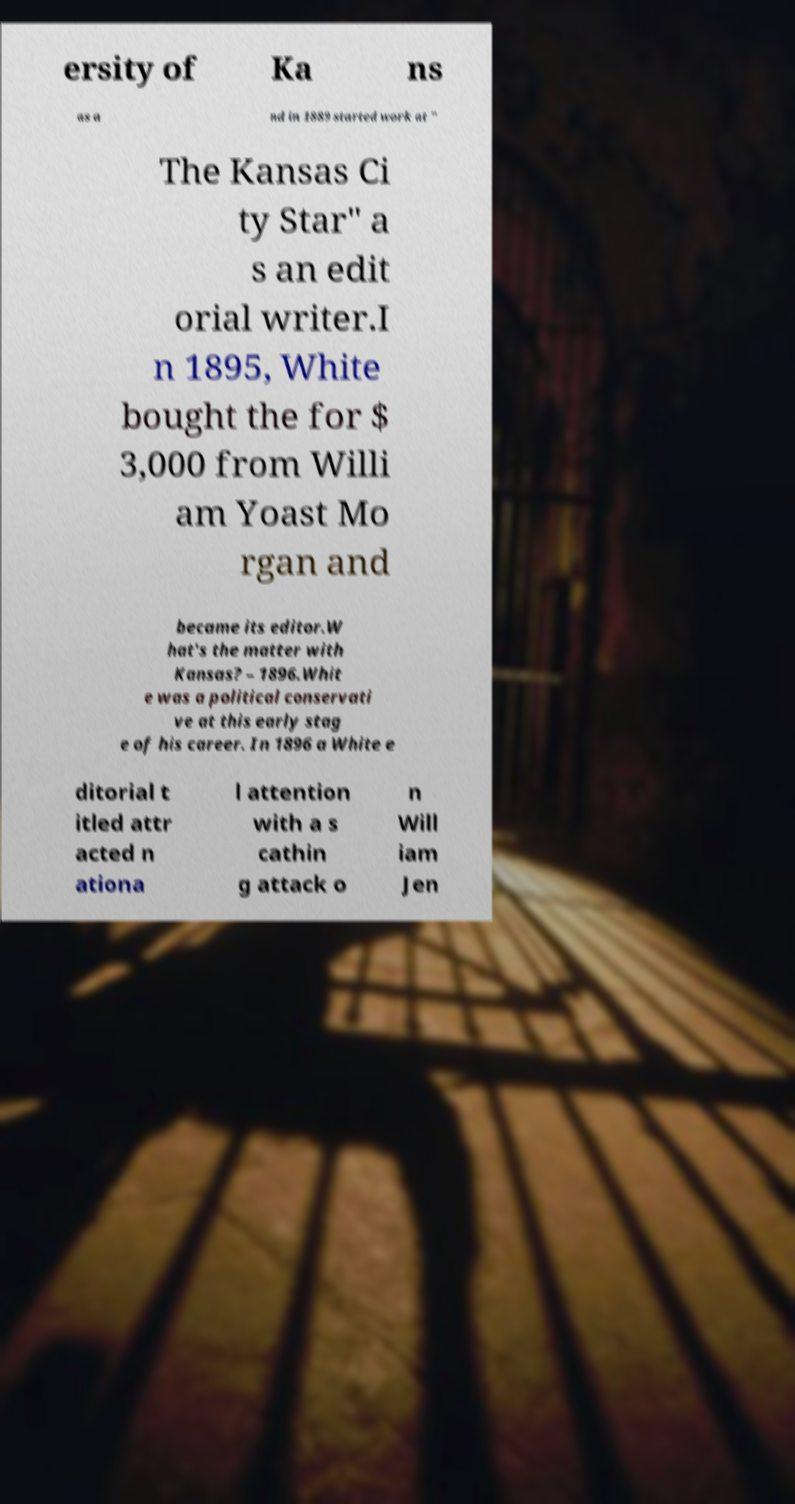Can you read and provide the text displayed in the image?This photo seems to have some interesting text. Can you extract and type it out for me? ersity of Ka ns as a nd in 1889 started work at " The Kansas Ci ty Star" a s an edit orial writer.I n 1895, White bought the for $ 3,000 from Willi am Yoast Mo rgan and became its editor.W hat's the matter with Kansas? – 1896.Whit e was a political conservati ve at this early stag e of his career. In 1896 a White e ditorial t itled attr acted n ationa l attention with a s cathin g attack o n Will iam Jen 